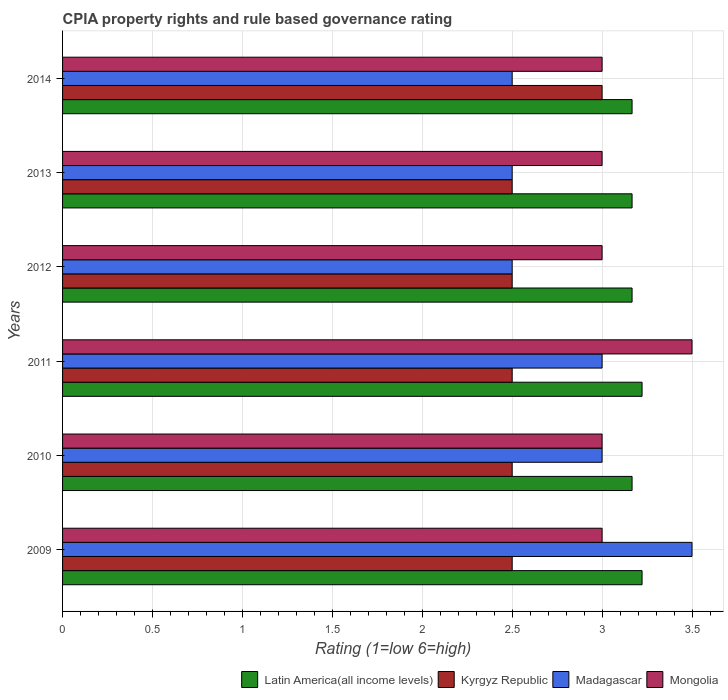How many groups of bars are there?
Your answer should be very brief. 6. Are the number of bars per tick equal to the number of legend labels?
Ensure brevity in your answer.  Yes. Are the number of bars on each tick of the Y-axis equal?
Keep it short and to the point. Yes. In how many cases, is the number of bars for a given year not equal to the number of legend labels?
Offer a very short reply. 0. Across all years, what is the minimum CPIA rating in Mongolia?
Provide a short and direct response. 3. In which year was the CPIA rating in Latin America(all income levels) maximum?
Keep it short and to the point. 2009. What is the total CPIA rating in Mongolia in the graph?
Keep it short and to the point. 18.5. What is the difference between the CPIA rating in Mongolia in 2010 and that in 2013?
Provide a short and direct response. 0. What is the difference between the CPIA rating in Kyrgyz Republic in 2009 and the CPIA rating in Latin America(all income levels) in 2012?
Provide a short and direct response. -0.67. What is the average CPIA rating in Latin America(all income levels) per year?
Offer a terse response. 3.19. What is the ratio of the CPIA rating in Kyrgyz Republic in 2012 to that in 2013?
Give a very brief answer. 1. Is the difference between the CPIA rating in Madagascar in 2010 and 2011 greater than the difference between the CPIA rating in Mongolia in 2010 and 2011?
Offer a terse response. Yes. What is the difference between the highest and the lowest CPIA rating in Kyrgyz Republic?
Make the answer very short. 0.5. Is it the case that in every year, the sum of the CPIA rating in Latin America(all income levels) and CPIA rating in Madagascar is greater than the sum of CPIA rating in Mongolia and CPIA rating in Kyrgyz Republic?
Offer a very short reply. No. What does the 1st bar from the top in 2010 represents?
Your answer should be compact. Mongolia. What does the 3rd bar from the bottom in 2012 represents?
Ensure brevity in your answer.  Madagascar. Is it the case that in every year, the sum of the CPIA rating in Latin America(all income levels) and CPIA rating in Madagascar is greater than the CPIA rating in Mongolia?
Keep it short and to the point. Yes. What is the difference between two consecutive major ticks on the X-axis?
Offer a terse response. 0.5. Are the values on the major ticks of X-axis written in scientific E-notation?
Provide a succinct answer. No. Does the graph contain any zero values?
Give a very brief answer. No. Does the graph contain grids?
Make the answer very short. Yes. What is the title of the graph?
Ensure brevity in your answer.  CPIA property rights and rule based governance rating. Does "Latvia" appear as one of the legend labels in the graph?
Keep it short and to the point. No. What is the label or title of the X-axis?
Offer a very short reply. Rating (1=low 6=high). What is the label or title of the Y-axis?
Ensure brevity in your answer.  Years. What is the Rating (1=low 6=high) of Latin America(all income levels) in 2009?
Ensure brevity in your answer.  3.22. What is the Rating (1=low 6=high) in Kyrgyz Republic in 2009?
Keep it short and to the point. 2.5. What is the Rating (1=low 6=high) in Madagascar in 2009?
Provide a short and direct response. 3.5. What is the Rating (1=low 6=high) in Latin America(all income levels) in 2010?
Offer a terse response. 3.17. What is the Rating (1=low 6=high) in Madagascar in 2010?
Your answer should be compact. 3. What is the Rating (1=low 6=high) in Mongolia in 2010?
Give a very brief answer. 3. What is the Rating (1=low 6=high) of Latin America(all income levels) in 2011?
Make the answer very short. 3.22. What is the Rating (1=low 6=high) in Madagascar in 2011?
Your answer should be compact. 3. What is the Rating (1=low 6=high) in Mongolia in 2011?
Provide a short and direct response. 3.5. What is the Rating (1=low 6=high) of Latin America(all income levels) in 2012?
Your answer should be very brief. 3.17. What is the Rating (1=low 6=high) of Mongolia in 2012?
Offer a very short reply. 3. What is the Rating (1=low 6=high) of Latin America(all income levels) in 2013?
Provide a succinct answer. 3.17. What is the Rating (1=low 6=high) in Kyrgyz Republic in 2013?
Your answer should be compact. 2.5. What is the Rating (1=low 6=high) in Madagascar in 2013?
Ensure brevity in your answer.  2.5. What is the Rating (1=low 6=high) in Latin America(all income levels) in 2014?
Offer a very short reply. 3.17. What is the Rating (1=low 6=high) in Madagascar in 2014?
Offer a terse response. 2.5. Across all years, what is the maximum Rating (1=low 6=high) of Latin America(all income levels)?
Keep it short and to the point. 3.22. Across all years, what is the maximum Rating (1=low 6=high) of Madagascar?
Your answer should be compact. 3.5. Across all years, what is the maximum Rating (1=low 6=high) of Mongolia?
Give a very brief answer. 3.5. Across all years, what is the minimum Rating (1=low 6=high) in Latin America(all income levels)?
Make the answer very short. 3.17. Across all years, what is the minimum Rating (1=low 6=high) of Mongolia?
Ensure brevity in your answer.  3. What is the total Rating (1=low 6=high) of Latin America(all income levels) in the graph?
Your answer should be very brief. 19.11. What is the total Rating (1=low 6=high) of Kyrgyz Republic in the graph?
Your response must be concise. 15.5. What is the total Rating (1=low 6=high) of Madagascar in the graph?
Provide a short and direct response. 17. What is the difference between the Rating (1=low 6=high) of Latin America(all income levels) in 2009 and that in 2010?
Keep it short and to the point. 0.06. What is the difference between the Rating (1=low 6=high) in Kyrgyz Republic in 2009 and that in 2010?
Provide a short and direct response. 0. What is the difference between the Rating (1=low 6=high) of Mongolia in 2009 and that in 2010?
Your response must be concise. 0. What is the difference between the Rating (1=low 6=high) of Latin America(all income levels) in 2009 and that in 2011?
Offer a very short reply. 0. What is the difference between the Rating (1=low 6=high) in Mongolia in 2009 and that in 2011?
Provide a short and direct response. -0.5. What is the difference between the Rating (1=low 6=high) in Latin America(all income levels) in 2009 and that in 2012?
Your answer should be very brief. 0.06. What is the difference between the Rating (1=low 6=high) of Kyrgyz Republic in 2009 and that in 2012?
Offer a very short reply. 0. What is the difference between the Rating (1=low 6=high) of Madagascar in 2009 and that in 2012?
Ensure brevity in your answer.  1. What is the difference between the Rating (1=low 6=high) in Latin America(all income levels) in 2009 and that in 2013?
Provide a succinct answer. 0.06. What is the difference between the Rating (1=low 6=high) of Madagascar in 2009 and that in 2013?
Your response must be concise. 1. What is the difference between the Rating (1=low 6=high) of Mongolia in 2009 and that in 2013?
Your answer should be compact. 0. What is the difference between the Rating (1=low 6=high) in Latin America(all income levels) in 2009 and that in 2014?
Your response must be concise. 0.06. What is the difference between the Rating (1=low 6=high) in Kyrgyz Republic in 2009 and that in 2014?
Keep it short and to the point. -0.5. What is the difference between the Rating (1=low 6=high) of Latin America(all income levels) in 2010 and that in 2011?
Offer a very short reply. -0.06. What is the difference between the Rating (1=low 6=high) in Madagascar in 2010 and that in 2011?
Make the answer very short. 0. What is the difference between the Rating (1=low 6=high) in Mongolia in 2010 and that in 2011?
Offer a very short reply. -0.5. What is the difference between the Rating (1=low 6=high) of Latin America(all income levels) in 2010 and that in 2012?
Make the answer very short. 0. What is the difference between the Rating (1=low 6=high) in Kyrgyz Republic in 2010 and that in 2012?
Ensure brevity in your answer.  0. What is the difference between the Rating (1=low 6=high) of Madagascar in 2010 and that in 2012?
Keep it short and to the point. 0.5. What is the difference between the Rating (1=low 6=high) of Madagascar in 2010 and that in 2013?
Provide a short and direct response. 0.5. What is the difference between the Rating (1=low 6=high) of Mongolia in 2010 and that in 2013?
Make the answer very short. 0. What is the difference between the Rating (1=low 6=high) of Madagascar in 2010 and that in 2014?
Ensure brevity in your answer.  0.5. What is the difference between the Rating (1=low 6=high) in Mongolia in 2010 and that in 2014?
Give a very brief answer. 0. What is the difference between the Rating (1=low 6=high) in Latin America(all income levels) in 2011 and that in 2012?
Keep it short and to the point. 0.06. What is the difference between the Rating (1=low 6=high) of Kyrgyz Republic in 2011 and that in 2012?
Provide a short and direct response. 0. What is the difference between the Rating (1=low 6=high) of Madagascar in 2011 and that in 2012?
Give a very brief answer. 0.5. What is the difference between the Rating (1=low 6=high) of Latin America(all income levels) in 2011 and that in 2013?
Keep it short and to the point. 0.06. What is the difference between the Rating (1=low 6=high) of Kyrgyz Republic in 2011 and that in 2013?
Give a very brief answer. 0. What is the difference between the Rating (1=low 6=high) of Mongolia in 2011 and that in 2013?
Offer a terse response. 0.5. What is the difference between the Rating (1=low 6=high) in Latin America(all income levels) in 2011 and that in 2014?
Provide a short and direct response. 0.06. What is the difference between the Rating (1=low 6=high) in Madagascar in 2011 and that in 2014?
Provide a short and direct response. 0.5. What is the difference between the Rating (1=low 6=high) in Mongolia in 2011 and that in 2014?
Your answer should be very brief. 0.5. What is the difference between the Rating (1=low 6=high) in Latin America(all income levels) in 2012 and that in 2013?
Make the answer very short. 0. What is the difference between the Rating (1=low 6=high) in Kyrgyz Republic in 2012 and that in 2013?
Provide a succinct answer. 0. What is the difference between the Rating (1=low 6=high) in Latin America(all income levels) in 2012 and that in 2014?
Your answer should be compact. 0. What is the difference between the Rating (1=low 6=high) in Mongolia in 2012 and that in 2014?
Offer a terse response. 0. What is the difference between the Rating (1=low 6=high) of Latin America(all income levels) in 2009 and the Rating (1=low 6=high) of Kyrgyz Republic in 2010?
Your answer should be very brief. 0.72. What is the difference between the Rating (1=low 6=high) of Latin America(all income levels) in 2009 and the Rating (1=low 6=high) of Madagascar in 2010?
Keep it short and to the point. 0.22. What is the difference between the Rating (1=low 6=high) of Latin America(all income levels) in 2009 and the Rating (1=low 6=high) of Mongolia in 2010?
Offer a very short reply. 0.22. What is the difference between the Rating (1=low 6=high) in Latin America(all income levels) in 2009 and the Rating (1=low 6=high) in Kyrgyz Republic in 2011?
Your answer should be compact. 0.72. What is the difference between the Rating (1=low 6=high) in Latin America(all income levels) in 2009 and the Rating (1=low 6=high) in Madagascar in 2011?
Give a very brief answer. 0.22. What is the difference between the Rating (1=low 6=high) in Latin America(all income levels) in 2009 and the Rating (1=low 6=high) in Mongolia in 2011?
Offer a very short reply. -0.28. What is the difference between the Rating (1=low 6=high) of Kyrgyz Republic in 2009 and the Rating (1=low 6=high) of Mongolia in 2011?
Offer a very short reply. -1. What is the difference between the Rating (1=low 6=high) of Madagascar in 2009 and the Rating (1=low 6=high) of Mongolia in 2011?
Provide a succinct answer. 0. What is the difference between the Rating (1=low 6=high) in Latin America(all income levels) in 2009 and the Rating (1=low 6=high) in Kyrgyz Republic in 2012?
Give a very brief answer. 0.72. What is the difference between the Rating (1=low 6=high) in Latin America(all income levels) in 2009 and the Rating (1=low 6=high) in Madagascar in 2012?
Provide a short and direct response. 0.72. What is the difference between the Rating (1=low 6=high) of Latin America(all income levels) in 2009 and the Rating (1=low 6=high) of Mongolia in 2012?
Your response must be concise. 0.22. What is the difference between the Rating (1=low 6=high) of Kyrgyz Republic in 2009 and the Rating (1=low 6=high) of Madagascar in 2012?
Ensure brevity in your answer.  0. What is the difference between the Rating (1=low 6=high) in Kyrgyz Republic in 2009 and the Rating (1=low 6=high) in Mongolia in 2012?
Provide a short and direct response. -0.5. What is the difference between the Rating (1=low 6=high) in Latin America(all income levels) in 2009 and the Rating (1=low 6=high) in Kyrgyz Republic in 2013?
Provide a succinct answer. 0.72. What is the difference between the Rating (1=low 6=high) of Latin America(all income levels) in 2009 and the Rating (1=low 6=high) of Madagascar in 2013?
Offer a terse response. 0.72. What is the difference between the Rating (1=low 6=high) in Latin America(all income levels) in 2009 and the Rating (1=low 6=high) in Mongolia in 2013?
Offer a terse response. 0.22. What is the difference between the Rating (1=low 6=high) of Kyrgyz Republic in 2009 and the Rating (1=low 6=high) of Madagascar in 2013?
Make the answer very short. 0. What is the difference between the Rating (1=low 6=high) in Madagascar in 2009 and the Rating (1=low 6=high) in Mongolia in 2013?
Provide a short and direct response. 0.5. What is the difference between the Rating (1=low 6=high) of Latin America(all income levels) in 2009 and the Rating (1=low 6=high) of Kyrgyz Republic in 2014?
Provide a short and direct response. 0.22. What is the difference between the Rating (1=low 6=high) in Latin America(all income levels) in 2009 and the Rating (1=low 6=high) in Madagascar in 2014?
Your answer should be compact. 0.72. What is the difference between the Rating (1=low 6=high) in Latin America(all income levels) in 2009 and the Rating (1=low 6=high) in Mongolia in 2014?
Offer a terse response. 0.22. What is the difference between the Rating (1=low 6=high) in Kyrgyz Republic in 2009 and the Rating (1=low 6=high) in Madagascar in 2014?
Provide a succinct answer. 0. What is the difference between the Rating (1=low 6=high) of Kyrgyz Republic in 2009 and the Rating (1=low 6=high) of Mongolia in 2014?
Keep it short and to the point. -0.5. What is the difference between the Rating (1=low 6=high) of Latin America(all income levels) in 2010 and the Rating (1=low 6=high) of Kyrgyz Republic in 2011?
Offer a terse response. 0.67. What is the difference between the Rating (1=low 6=high) in Latin America(all income levels) in 2010 and the Rating (1=low 6=high) in Madagascar in 2011?
Provide a succinct answer. 0.17. What is the difference between the Rating (1=low 6=high) in Kyrgyz Republic in 2010 and the Rating (1=low 6=high) in Madagascar in 2011?
Give a very brief answer. -0.5. What is the difference between the Rating (1=low 6=high) of Madagascar in 2010 and the Rating (1=low 6=high) of Mongolia in 2011?
Offer a terse response. -0.5. What is the difference between the Rating (1=low 6=high) of Latin America(all income levels) in 2010 and the Rating (1=low 6=high) of Kyrgyz Republic in 2012?
Offer a terse response. 0.67. What is the difference between the Rating (1=low 6=high) of Latin America(all income levels) in 2010 and the Rating (1=low 6=high) of Madagascar in 2012?
Keep it short and to the point. 0.67. What is the difference between the Rating (1=low 6=high) of Latin America(all income levels) in 2010 and the Rating (1=low 6=high) of Mongolia in 2012?
Provide a succinct answer. 0.17. What is the difference between the Rating (1=low 6=high) in Kyrgyz Republic in 2010 and the Rating (1=low 6=high) in Mongolia in 2012?
Give a very brief answer. -0.5. What is the difference between the Rating (1=low 6=high) in Kyrgyz Republic in 2010 and the Rating (1=low 6=high) in Madagascar in 2013?
Your answer should be compact. 0. What is the difference between the Rating (1=low 6=high) in Madagascar in 2010 and the Rating (1=low 6=high) in Mongolia in 2013?
Provide a short and direct response. 0. What is the difference between the Rating (1=low 6=high) of Latin America(all income levels) in 2010 and the Rating (1=low 6=high) of Kyrgyz Republic in 2014?
Offer a very short reply. 0.17. What is the difference between the Rating (1=low 6=high) of Latin America(all income levels) in 2010 and the Rating (1=low 6=high) of Madagascar in 2014?
Keep it short and to the point. 0.67. What is the difference between the Rating (1=low 6=high) of Latin America(all income levels) in 2010 and the Rating (1=low 6=high) of Mongolia in 2014?
Make the answer very short. 0.17. What is the difference between the Rating (1=low 6=high) of Latin America(all income levels) in 2011 and the Rating (1=low 6=high) of Kyrgyz Republic in 2012?
Offer a terse response. 0.72. What is the difference between the Rating (1=low 6=high) in Latin America(all income levels) in 2011 and the Rating (1=low 6=high) in Madagascar in 2012?
Keep it short and to the point. 0.72. What is the difference between the Rating (1=low 6=high) in Latin America(all income levels) in 2011 and the Rating (1=low 6=high) in Mongolia in 2012?
Your response must be concise. 0.22. What is the difference between the Rating (1=low 6=high) of Kyrgyz Republic in 2011 and the Rating (1=low 6=high) of Mongolia in 2012?
Your answer should be compact. -0.5. What is the difference between the Rating (1=low 6=high) of Latin America(all income levels) in 2011 and the Rating (1=low 6=high) of Kyrgyz Republic in 2013?
Offer a terse response. 0.72. What is the difference between the Rating (1=low 6=high) in Latin America(all income levels) in 2011 and the Rating (1=low 6=high) in Madagascar in 2013?
Provide a succinct answer. 0.72. What is the difference between the Rating (1=low 6=high) of Latin America(all income levels) in 2011 and the Rating (1=low 6=high) of Mongolia in 2013?
Give a very brief answer. 0.22. What is the difference between the Rating (1=low 6=high) of Kyrgyz Republic in 2011 and the Rating (1=low 6=high) of Madagascar in 2013?
Your response must be concise. 0. What is the difference between the Rating (1=low 6=high) of Kyrgyz Republic in 2011 and the Rating (1=low 6=high) of Mongolia in 2013?
Your response must be concise. -0.5. What is the difference between the Rating (1=low 6=high) in Madagascar in 2011 and the Rating (1=low 6=high) in Mongolia in 2013?
Your response must be concise. 0. What is the difference between the Rating (1=low 6=high) of Latin America(all income levels) in 2011 and the Rating (1=low 6=high) of Kyrgyz Republic in 2014?
Your response must be concise. 0.22. What is the difference between the Rating (1=low 6=high) of Latin America(all income levels) in 2011 and the Rating (1=low 6=high) of Madagascar in 2014?
Your answer should be very brief. 0.72. What is the difference between the Rating (1=low 6=high) of Latin America(all income levels) in 2011 and the Rating (1=low 6=high) of Mongolia in 2014?
Offer a very short reply. 0.22. What is the difference between the Rating (1=low 6=high) of Kyrgyz Republic in 2011 and the Rating (1=low 6=high) of Madagascar in 2014?
Your response must be concise. 0. What is the difference between the Rating (1=low 6=high) in Kyrgyz Republic in 2011 and the Rating (1=low 6=high) in Mongolia in 2014?
Keep it short and to the point. -0.5. What is the difference between the Rating (1=low 6=high) in Latin America(all income levels) in 2012 and the Rating (1=low 6=high) in Mongolia in 2013?
Provide a short and direct response. 0.17. What is the difference between the Rating (1=low 6=high) in Latin America(all income levels) in 2012 and the Rating (1=low 6=high) in Kyrgyz Republic in 2014?
Provide a short and direct response. 0.17. What is the difference between the Rating (1=low 6=high) in Kyrgyz Republic in 2012 and the Rating (1=low 6=high) in Madagascar in 2014?
Your answer should be very brief. 0. What is the difference between the Rating (1=low 6=high) of Madagascar in 2012 and the Rating (1=low 6=high) of Mongolia in 2014?
Keep it short and to the point. -0.5. What is the difference between the Rating (1=low 6=high) in Latin America(all income levels) in 2013 and the Rating (1=low 6=high) in Kyrgyz Republic in 2014?
Offer a terse response. 0.17. What is the average Rating (1=low 6=high) of Latin America(all income levels) per year?
Make the answer very short. 3.19. What is the average Rating (1=low 6=high) in Kyrgyz Republic per year?
Give a very brief answer. 2.58. What is the average Rating (1=low 6=high) in Madagascar per year?
Ensure brevity in your answer.  2.83. What is the average Rating (1=low 6=high) of Mongolia per year?
Keep it short and to the point. 3.08. In the year 2009, what is the difference between the Rating (1=low 6=high) in Latin America(all income levels) and Rating (1=low 6=high) in Kyrgyz Republic?
Provide a short and direct response. 0.72. In the year 2009, what is the difference between the Rating (1=low 6=high) of Latin America(all income levels) and Rating (1=low 6=high) of Madagascar?
Make the answer very short. -0.28. In the year 2009, what is the difference between the Rating (1=low 6=high) of Latin America(all income levels) and Rating (1=low 6=high) of Mongolia?
Make the answer very short. 0.22. In the year 2009, what is the difference between the Rating (1=low 6=high) in Kyrgyz Republic and Rating (1=low 6=high) in Madagascar?
Make the answer very short. -1. In the year 2009, what is the difference between the Rating (1=low 6=high) of Kyrgyz Republic and Rating (1=low 6=high) of Mongolia?
Offer a very short reply. -0.5. In the year 2010, what is the difference between the Rating (1=low 6=high) of Kyrgyz Republic and Rating (1=low 6=high) of Madagascar?
Ensure brevity in your answer.  -0.5. In the year 2010, what is the difference between the Rating (1=low 6=high) in Kyrgyz Republic and Rating (1=low 6=high) in Mongolia?
Ensure brevity in your answer.  -0.5. In the year 2011, what is the difference between the Rating (1=low 6=high) of Latin America(all income levels) and Rating (1=low 6=high) of Kyrgyz Republic?
Give a very brief answer. 0.72. In the year 2011, what is the difference between the Rating (1=low 6=high) of Latin America(all income levels) and Rating (1=low 6=high) of Madagascar?
Offer a terse response. 0.22. In the year 2011, what is the difference between the Rating (1=low 6=high) in Latin America(all income levels) and Rating (1=low 6=high) in Mongolia?
Your response must be concise. -0.28. In the year 2011, what is the difference between the Rating (1=low 6=high) in Madagascar and Rating (1=low 6=high) in Mongolia?
Ensure brevity in your answer.  -0.5. In the year 2012, what is the difference between the Rating (1=low 6=high) of Latin America(all income levels) and Rating (1=low 6=high) of Mongolia?
Provide a short and direct response. 0.17. In the year 2012, what is the difference between the Rating (1=low 6=high) in Kyrgyz Republic and Rating (1=low 6=high) in Madagascar?
Keep it short and to the point. 0. In the year 2012, what is the difference between the Rating (1=low 6=high) in Kyrgyz Republic and Rating (1=low 6=high) in Mongolia?
Offer a very short reply. -0.5. In the year 2013, what is the difference between the Rating (1=low 6=high) in Latin America(all income levels) and Rating (1=low 6=high) in Kyrgyz Republic?
Offer a very short reply. 0.67. In the year 2013, what is the difference between the Rating (1=low 6=high) in Kyrgyz Republic and Rating (1=low 6=high) in Madagascar?
Your answer should be compact. 0. In the year 2014, what is the difference between the Rating (1=low 6=high) in Latin America(all income levels) and Rating (1=low 6=high) in Mongolia?
Provide a succinct answer. 0.17. What is the ratio of the Rating (1=low 6=high) in Latin America(all income levels) in 2009 to that in 2010?
Offer a very short reply. 1.02. What is the ratio of the Rating (1=low 6=high) of Kyrgyz Republic in 2009 to that in 2011?
Offer a terse response. 1. What is the ratio of the Rating (1=low 6=high) of Latin America(all income levels) in 2009 to that in 2012?
Provide a short and direct response. 1.02. What is the ratio of the Rating (1=low 6=high) in Madagascar in 2009 to that in 2012?
Offer a terse response. 1.4. What is the ratio of the Rating (1=low 6=high) in Mongolia in 2009 to that in 2012?
Make the answer very short. 1. What is the ratio of the Rating (1=low 6=high) of Latin America(all income levels) in 2009 to that in 2013?
Offer a very short reply. 1.02. What is the ratio of the Rating (1=low 6=high) of Kyrgyz Republic in 2009 to that in 2013?
Ensure brevity in your answer.  1. What is the ratio of the Rating (1=low 6=high) of Latin America(all income levels) in 2009 to that in 2014?
Your response must be concise. 1.02. What is the ratio of the Rating (1=low 6=high) in Madagascar in 2009 to that in 2014?
Ensure brevity in your answer.  1.4. What is the ratio of the Rating (1=low 6=high) of Latin America(all income levels) in 2010 to that in 2011?
Keep it short and to the point. 0.98. What is the ratio of the Rating (1=low 6=high) in Madagascar in 2010 to that in 2011?
Offer a very short reply. 1. What is the ratio of the Rating (1=low 6=high) in Mongolia in 2010 to that in 2011?
Make the answer very short. 0.86. What is the ratio of the Rating (1=low 6=high) in Latin America(all income levels) in 2010 to that in 2012?
Offer a terse response. 1. What is the ratio of the Rating (1=low 6=high) of Kyrgyz Republic in 2010 to that in 2012?
Provide a succinct answer. 1. What is the ratio of the Rating (1=low 6=high) of Madagascar in 2010 to that in 2012?
Ensure brevity in your answer.  1.2. What is the ratio of the Rating (1=low 6=high) of Latin America(all income levels) in 2010 to that in 2013?
Your response must be concise. 1. What is the ratio of the Rating (1=low 6=high) of Kyrgyz Republic in 2010 to that in 2014?
Your response must be concise. 0.83. What is the ratio of the Rating (1=low 6=high) in Mongolia in 2010 to that in 2014?
Your answer should be very brief. 1. What is the ratio of the Rating (1=low 6=high) in Latin America(all income levels) in 2011 to that in 2012?
Your answer should be very brief. 1.02. What is the ratio of the Rating (1=low 6=high) of Mongolia in 2011 to that in 2012?
Provide a succinct answer. 1.17. What is the ratio of the Rating (1=low 6=high) in Latin America(all income levels) in 2011 to that in 2013?
Offer a terse response. 1.02. What is the ratio of the Rating (1=low 6=high) in Kyrgyz Republic in 2011 to that in 2013?
Offer a terse response. 1. What is the ratio of the Rating (1=low 6=high) of Mongolia in 2011 to that in 2013?
Offer a very short reply. 1.17. What is the ratio of the Rating (1=low 6=high) in Latin America(all income levels) in 2011 to that in 2014?
Provide a short and direct response. 1.02. What is the ratio of the Rating (1=low 6=high) in Madagascar in 2011 to that in 2014?
Make the answer very short. 1.2. What is the ratio of the Rating (1=low 6=high) in Kyrgyz Republic in 2012 to that in 2013?
Your answer should be very brief. 1. What is the ratio of the Rating (1=low 6=high) in Mongolia in 2012 to that in 2014?
Offer a very short reply. 1. What is the ratio of the Rating (1=low 6=high) of Kyrgyz Republic in 2013 to that in 2014?
Make the answer very short. 0.83. What is the ratio of the Rating (1=low 6=high) in Madagascar in 2013 to that in 2014?
Offer a terse response. 1. What is the difference between the highest and the second highest Rating (1=low 6=high) in Latin America(all income levels)?
Your response must be concise. 0. What is the difference between the highest and the second highest Rating (1=low 6=high) in Kyrgyz Republic?
Your response must be concise. 0.5. What is the difference between the highest and the second highest Rating (1=low 6=high) of Mongolia?
Your response must be concise. 0.5. What is the difference between the highest and the lowest Rating (1=low 6=high) of Latin America(all income levels)?
Give a very brief answer. 0.06. What is the difference between the highest and the lowest Rating (1=low 6=high) in Kyrgyz Republic?
Your response must be concise. 0.5. What is the difference between the highest and the lowest Rating (1=low 6=high) in Mongolia?
Ensure brevity in your answer.  0.5. 